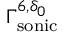<formula> <loc_0><loc_0><loc_500><loc_500>\Gamma _ { s o n i c } ^ { 6 , \delta _ { 0 } }</formula> 